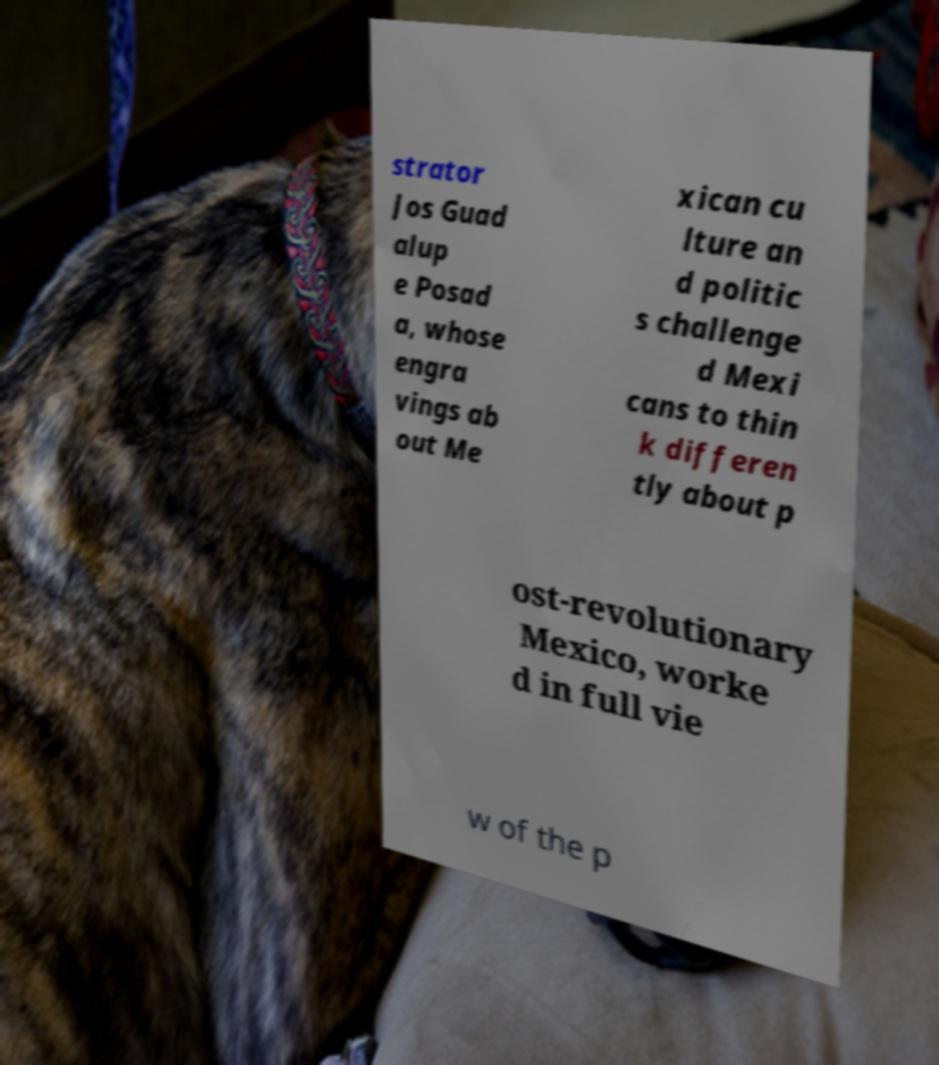For documentation purposes, I need the text within this image transcribed. Could you provide that? strator Jos Guad alup e Posad a, whose engra vings ab out Me xican cu lture an d politic s challenge d Mexi cans to thin k differen tly about p ost-revolutionary Mexico, worke d in full vie w of the p 